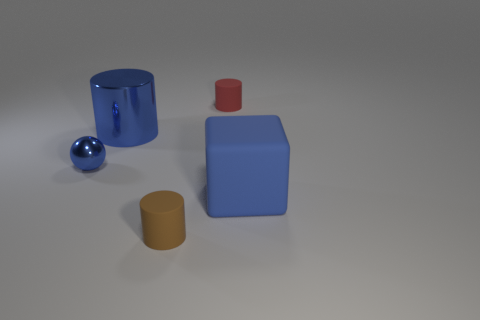Add 3 small red rubber cylinders. How many objects exist? 8 Subtract all cylinders. How many objects are left? 2 Add 5 small balls. How many small balls exist? 6 Subtract 0 green cylinders. How many objects are left? 5 Subtract all red things. Subtract all small metal objects. How many objects are left? 3 Add 3 blue metal cylinders. How many blue metal cylinders are left? 4 